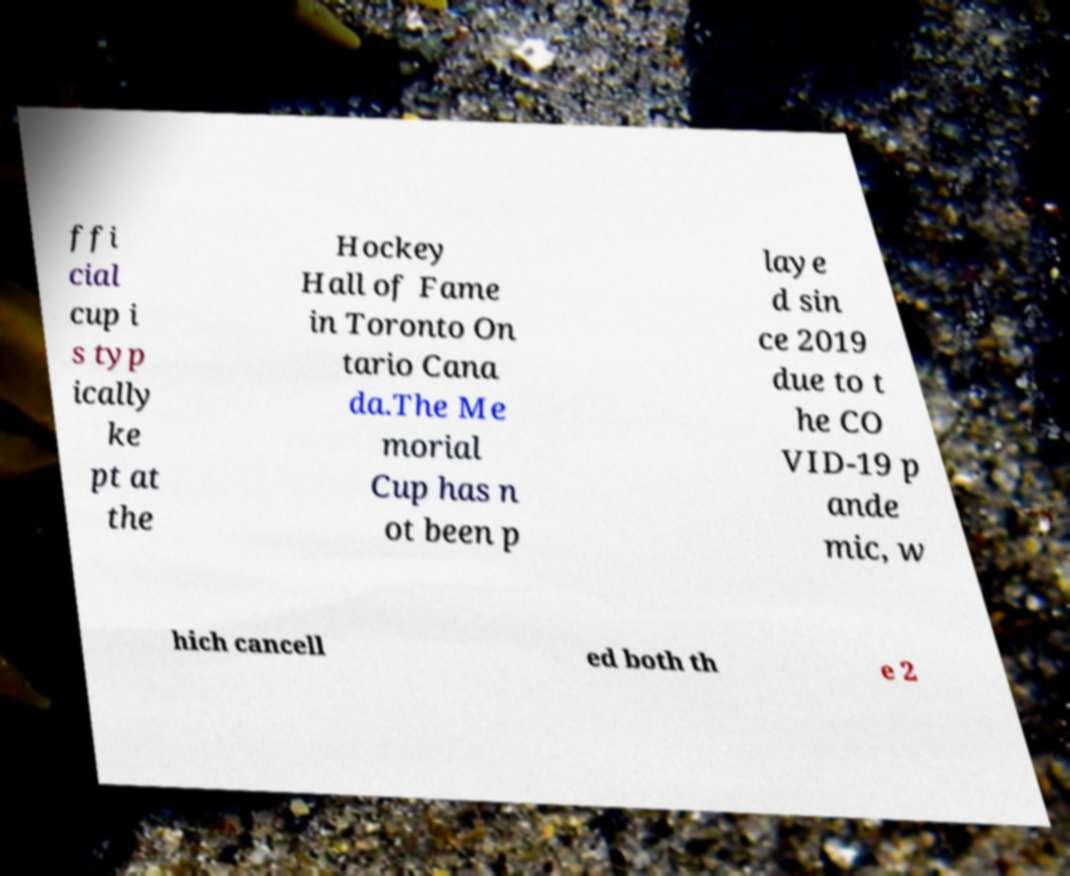Can you accurately transcribe the text from the provided image for me? ffi cial cup i s typ ically ke pt at the Hockey Hall of Fame in Toronto On tario Cana da.The Me morial Cup has n ot been p laye d sin ce 2019 due to t he CO VID-19 p ande mic, w hich cancell ed both th e 2 